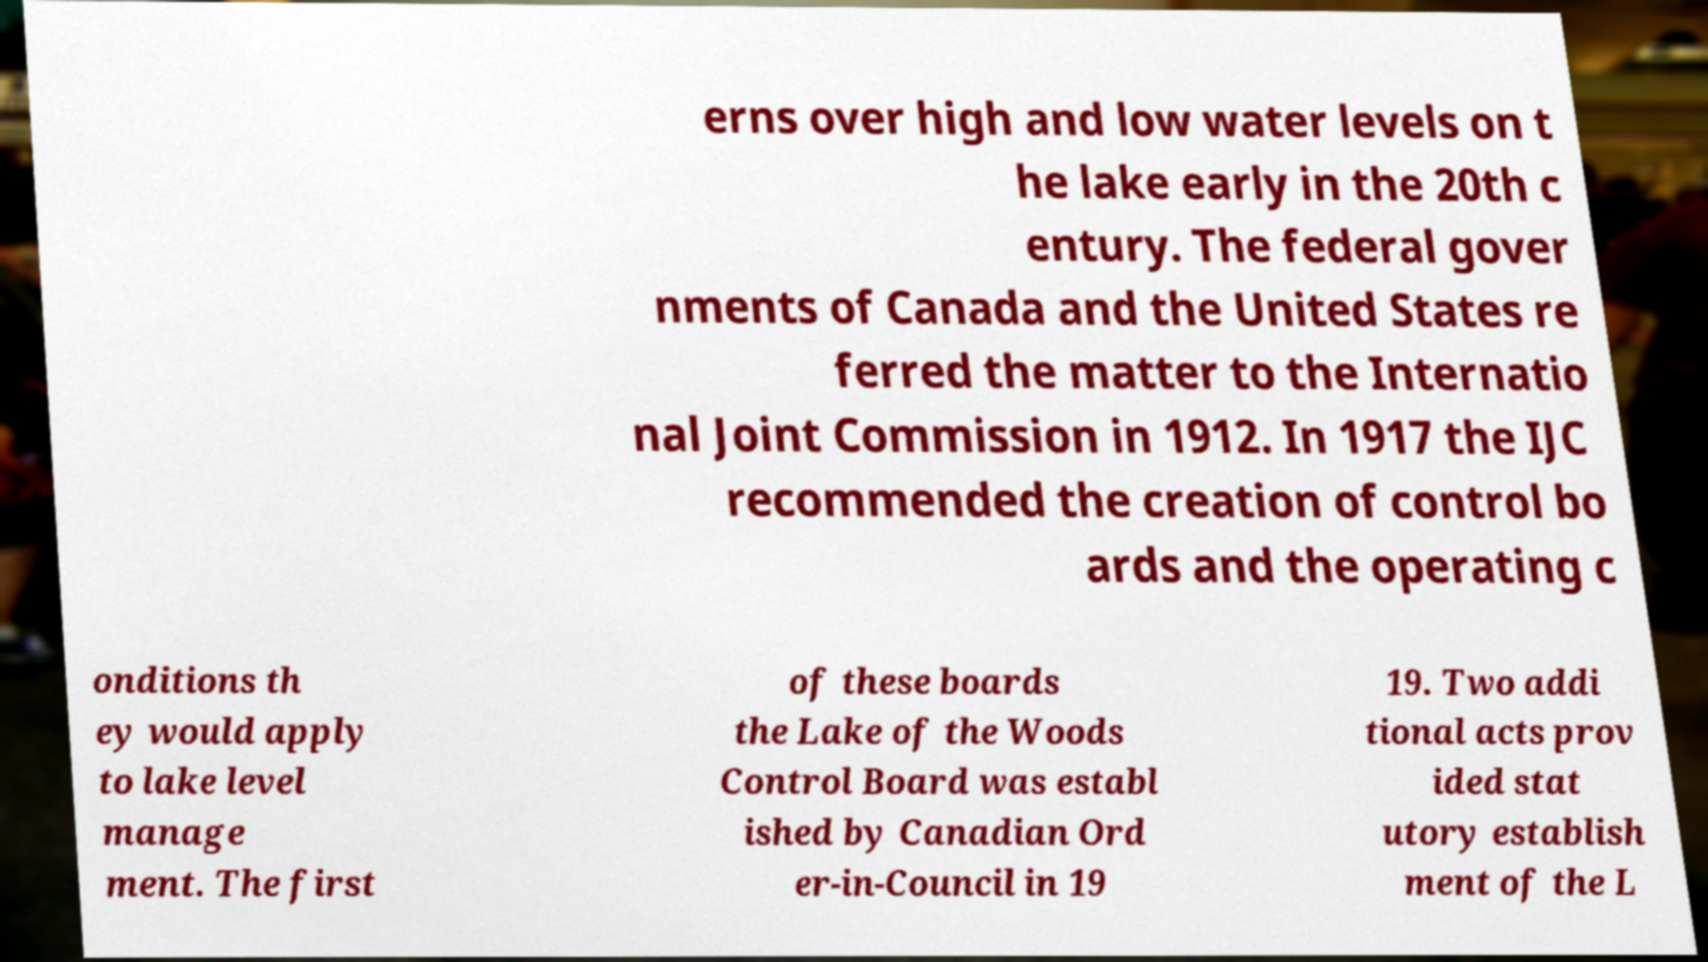Could you assist in decoding the text presented in this image and type it out clearly? erns over high and low water levels on t he lake early in the 20th c entury. The federal gover nments of Canada and the United States re ferred the matter to the Internatio nal Joint Commission in 1912. In 1917 the IJC recommended the creation of control bo ards and the operating c onditions th ey would apply to lake level manage ment. The first of these boards the Lake of the Woods Control Board was establ ished by Canadian Ord er-in-Council in 19 19. Two addi tional acts prov ided stat utory establish ment of the L 